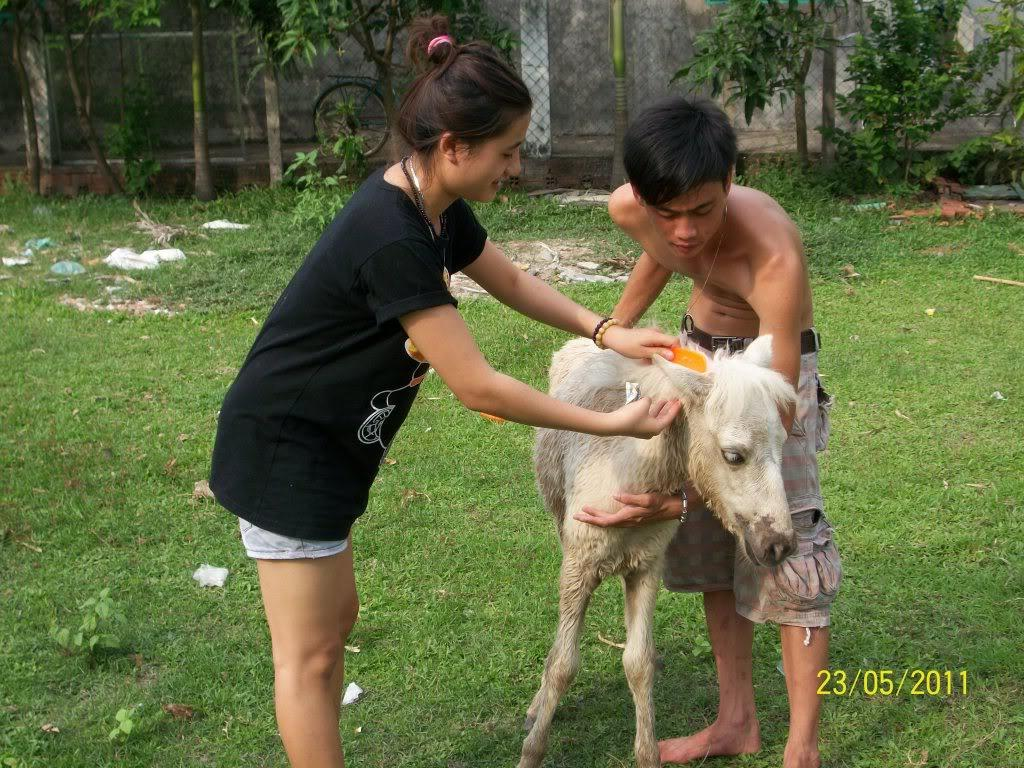How many people are in the image? There are two persons in the image. What are the persons doing in the image? The persons are standing and holding an animal. What can be seen in the background of the image? There are plants, a bicycle, and grass in the background of the image. Is there any indication of the image's origin or ownership? Yes, there is a watermark on the image. Can you describe the hill in the background of the image? There is no hill present in the background of the image. What type of room is visible in the image? The image does not depict a room; it shows two persons holding an animal outdoors. 